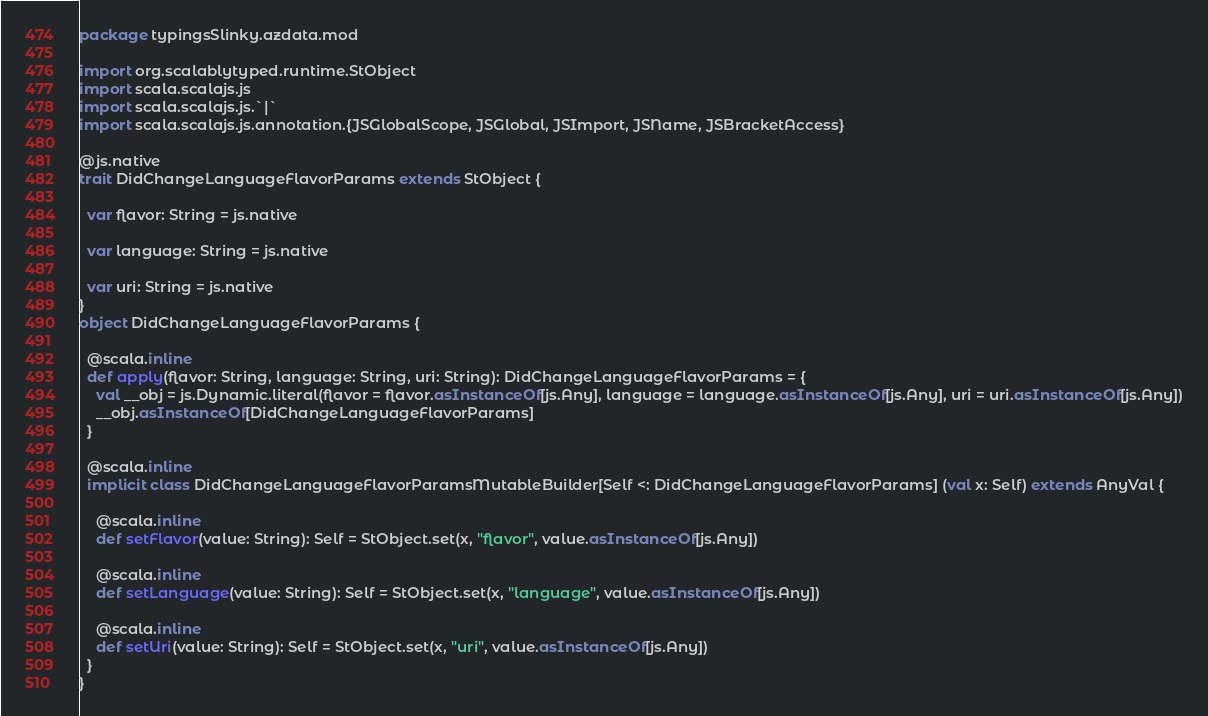Convert code to text. <code><loc_0><loc_0><loc_500><loc_500><_Scala_>package typingsSlinky.azdata.mod

import org.scalablytyped.runtime.StObject
import scala.scalajs.js
import scala.scalajs.js.`|`
import scala.scalajs.js.annotation.{JSGlobalScope, JSGlobal, JSImport, JSName, JSBracketAccess}

@js.native
trait DidChangeLanguageFlavorParams extends StObject {
  
  var flavor: String = js.native
  
  var language: String = js.native
  
  var uri: String = js.native
}
object DidChangeLanguageFlavorParams {
  
  @scala.inline
  def apply(flavor: String, language: String, uri: String): DidChangeLanguageFlavorParams = {
    val __obj = js.Dynamic.literal(flavor = flavor.asInstanceOf[js.Any], language = language.asInstanceOf[js.Any], uri = uri.asInstanceOf[js.Any])
    __obj.asInstanceOf[DidChangeLanguageFlavorParams]
  }
  
  @scala.inline
  implicit class DidChangeLanguageFlavorParamsMutableBuilder[Self <: DidChangeLanguageFlavorParams] (val x: Self) extends AnyVal {
    
    @scala.inline
    def setFlavor(value: String): Self = StObject.set(x, "flavor", value.asInstanceOf[js.Any])
    
    @scala.inline
    def setLanguage(value: String): Self = StObject.set(x, "language", value.asInstanceOf[js.Any])
    
    @scala.inline
    def setUri(value: String): Self = StObject.set(x, "uri", value.asInstanceOf[js.Any])
  }
}
</code> 